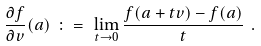<formula> <loc_0><loc_0><loc_500><loc_500>\frac { \partial f } { \partial v } ( a ) \ \colon = \ \lim _ { t \to 0 } \frac { f ( a + t v ) - f ( a ) } { t } \ .</formula> 